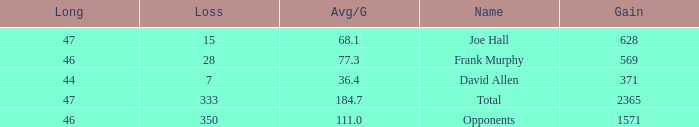How much Avg/G has a Gain smaller than 1571, and a Long smaller than 46? 1.0. 